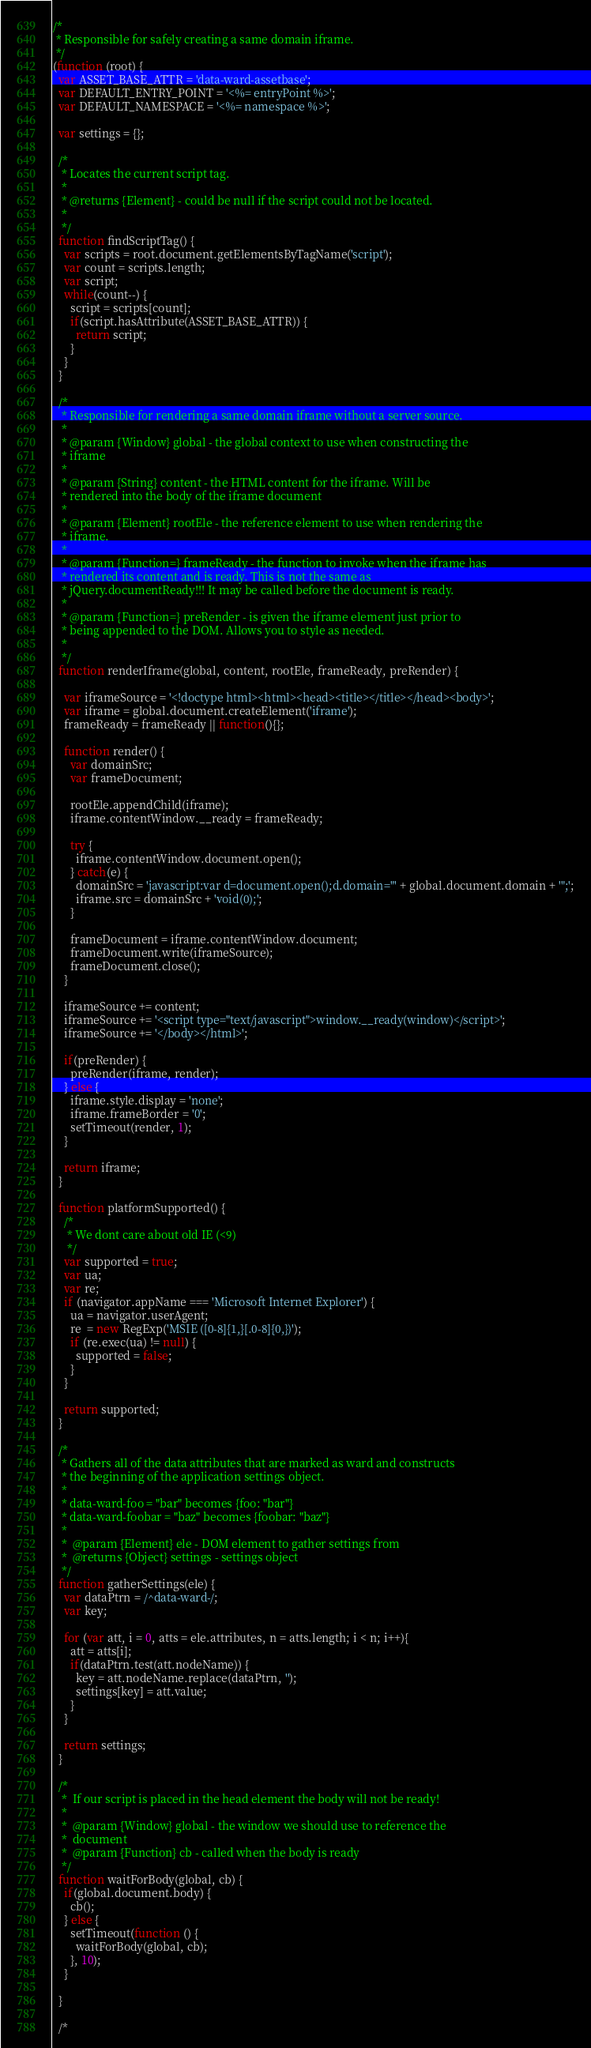Convert code to text. <code><loc_0><loc_0><loc_500><loc_500><_JavaScript_>/*
 * Responsible for safely creating a same domain iframe.
 */
(function (root) {
  var ASSET_BASE_ATTR = 'data-ward-assetbase';
  var DEFAULT_ENTRY_POINT = '<%= entryPoint %>';
  var DEFAULT_NAMESPACE = '<%= namespace %>';

  var settings = {};

  /*
   * Locates the current script tag.
   *
   * @returns {Element} - could be null if the script could not be located.
   *
   */
  function findScriptTag() {
    var scripts = root.document.getElementsByTagName('script');
    var count = scripts.length;
    var script;
    while(count--) {
      script = scripts[count];
      if(script.hasAttribute(ASSET_BASE_ATTR)) {
        return script;
      }
    }
  }

  /*
   * Responsible for rendering a same domain iframe without a server source.
   *
   * @param {Window} global - the global context to use when constructing the
   * iframe
   *
   * @param {String} content - the HTML content for the iframe. Will be
   * rendered into the body of the iframe document
   *
   * @param {Element} rootEle - the reference element to use when rendering the
   * iframe.
   *
   * @param {Function=} frameReady - the function to invoke when the iframe has
   * rendered its content and is ready. This is not the same as
   * jQuery.documentReady!!! It may be called before the document is ready.
   *
   * @param {Function=} preRender - is given the iframe element just prior to
   * being appended to the DOM. Allows you to style as needed.
   *
   */
  function renderIframe(global, content, rootEle, frameReady, preRender) {

    var iframeSource = '<!doctype html><html><head><title></title></head><body>';
    var iframe = global.document.createElement('iframe');
    frameReady = frameReady || function(){};

    function render() {
      var domainSrc;
      var frameDocument;

      rootEle.appendChild(iframe);
      iframe.contentWindow.__ready = frameReady;

      try {
        iframe.contentWindow.document.open();
      } catch(e) {
        domainSrc = 'javascript:var d=document.open();d.domain="' + global.document.domain + '";';
        iframe.src = domainSrc + 'void(0);';
      }

      frameDocument = iframe.contentWindow.document;
      frameDocument.write(iframeSource);
      frameDocument.close();
    }

    iframeSource += content;
    iframeSource += '<script type="text/javascript">window.__ready(window)</script>';
    iframeSource += '</body></html>';

    if(preRender) {
      preRender(iframe, render);
    } else {
      iframe.style.display = 'none';
      iframe.frameBorder = '0';
      setTimeout(render, 1);
    }

    return iframe;
  }

  function platformSupported() {
    /*
     * We dont care about old IE (<9)
     */
    var supported = true;
    var ua;
    var re;
    if (navigator.appName === 'Microsoft Internet Explorer') {
      ua = navigator.userAgent;
      re  = new RegExp('MSIE ([0-8]{1,}[.0-8]{0,})');
      if (re.exec(ua) != null) {
        supported = false;
      }
    }

    return supported;
  }

  /*
   * Gathers all of the data attributes that are marked as ward and constructs
   * the beginning of the application settings object.
   *
   * data-ward-foo = "bar" becomes {foo: "bar"}
   * data-ward-foobar = "baz" becomes {foobar: "baz"}
   *
   *  @param {Element} ele - DOM element to gather settings from
   *  @returns {Object} settings - settings object
   */
  function gatherSettings(ele) {
    var dataPtrn = /^data-ward-/;
    var key;

    for (var att, i = 0, atts = ele.attributes, n = atts.length; i < n; i++){
      att = atts[i];
      if(dataPtrn.test(att.nodeName)) {
        key = att.nodeName.replace(dataPtrn, '');
        settings[key] = att.value;
      }
    }

    return settings;
  }

  /*
   *  If our script is placed in the head element the body will not be ready!
   *
   *  @param {Window} global - the window we should use to reference the
   *  document
   *  @param {Function} cb - called when the body is ready
   */
  function waitForBody(global, cb) {
    if(global.document.body) {
      cb();
    } else {
      setTimeout(function () {
        waitForBody(global, cb);
      }, 10);
    }

  }

  /*</code> 